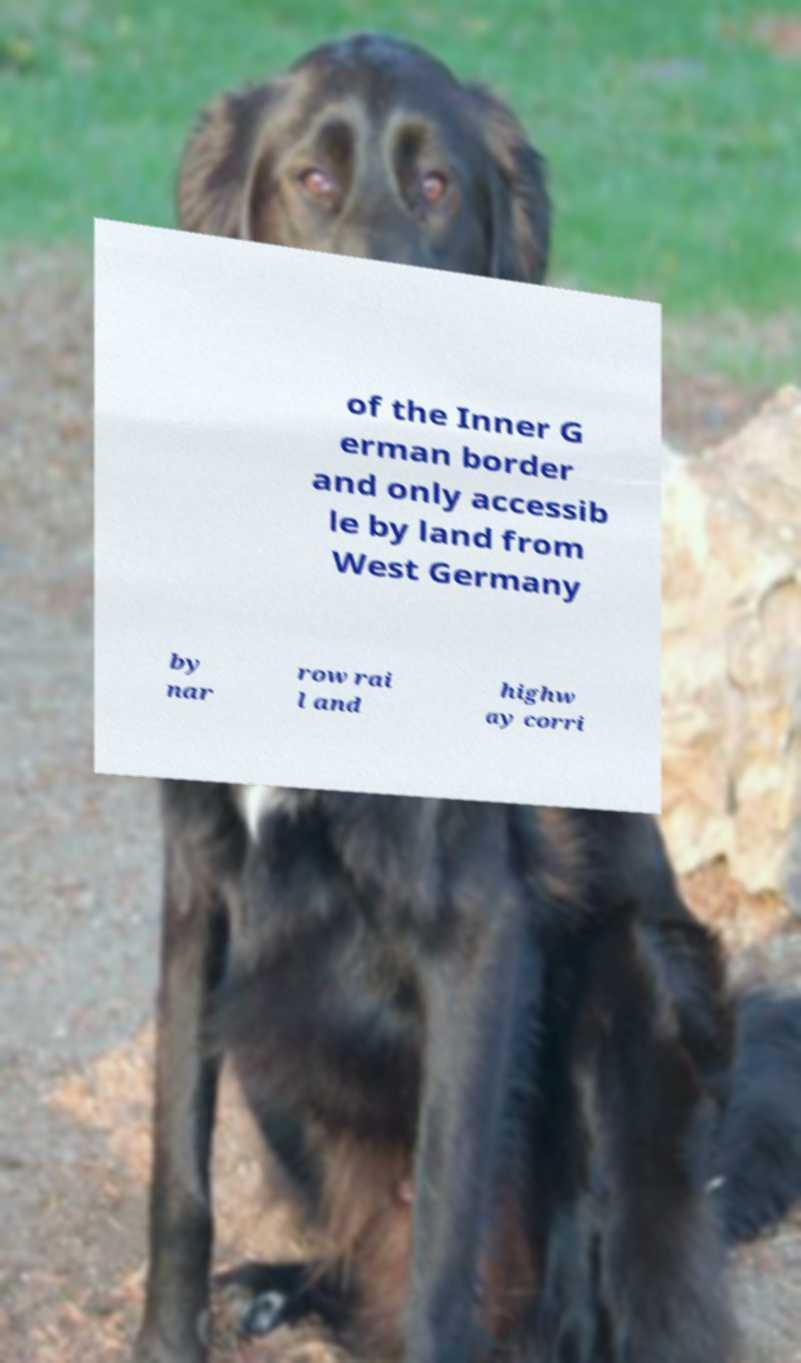Please read and relay the text visible in this image. What does it say? of the Inner G erman border and only accessib le by land from West Germany by nar row rai l and highw ay corri 